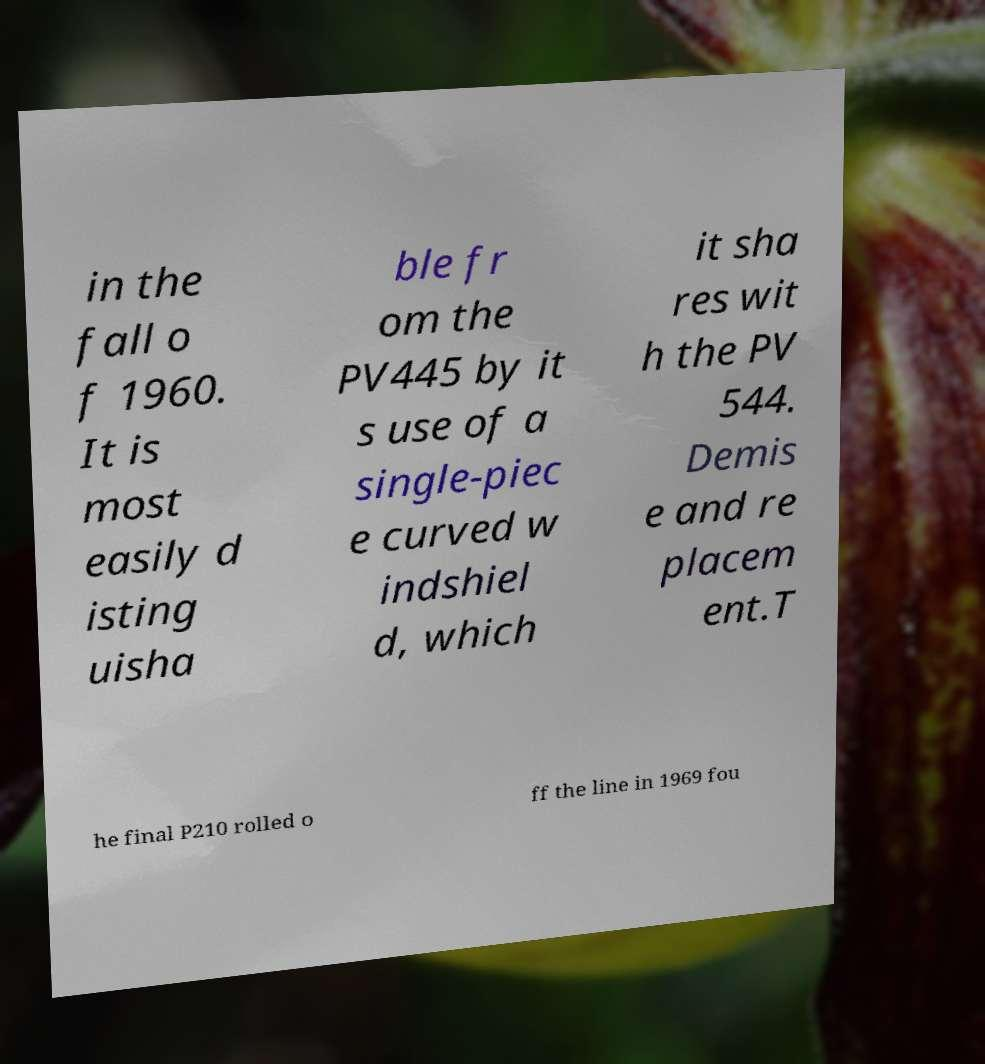Please read and relay the text visible in this image. What does it say? in the fall o f 1960. It is most easily d isting uisha ble fr om the PV445 by it s use of a single-piec e curved w indshiel d, which it sha res wit h the PV 544. Demis e and re placem ent.T he final P210 rolled o ff the line in 1969 fou 